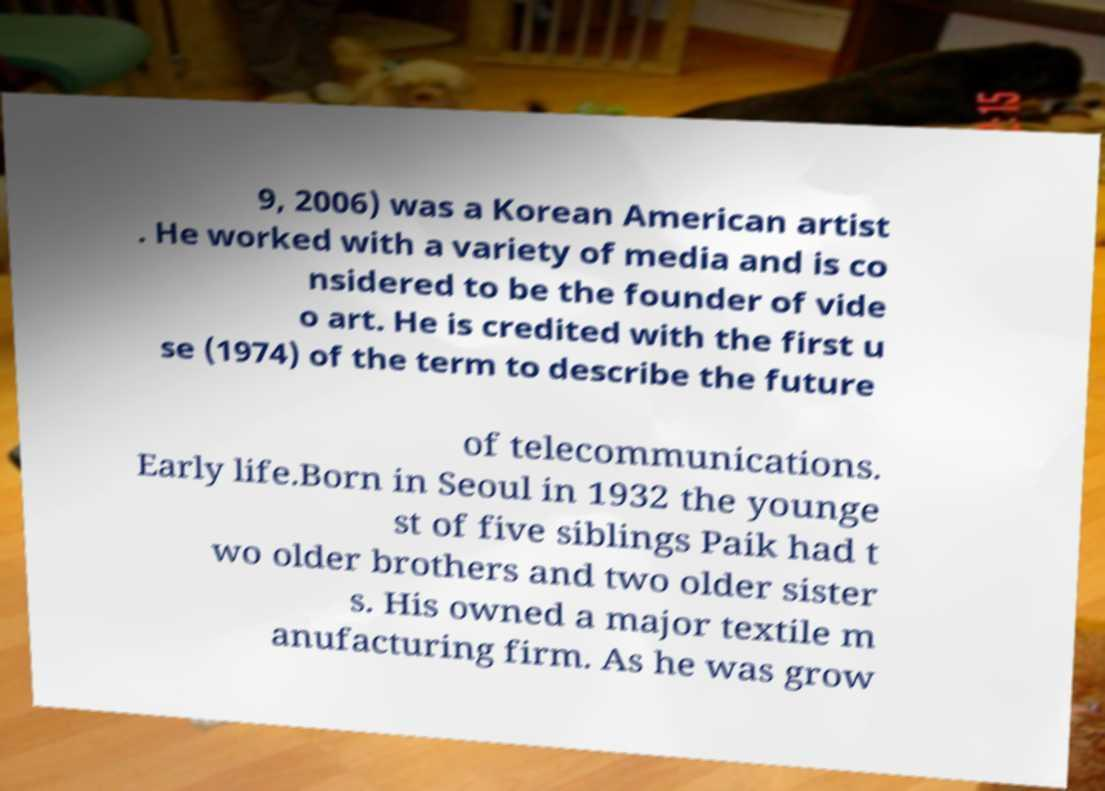Please read and relay the text visible in this image. What does it say? 9, 2006) was a Korean American artist . He worked with a variety of media and is co nsidered to be the founder of vide o art. He is credited with the first u se (1974) of the term to describe the future of telecommunications. Early life.Born in Seoul in 1932 the younge st of five siblings Paik had t wo older brothers and two older sister s. His owned a major textile m anufacturing firm. As he was grow 